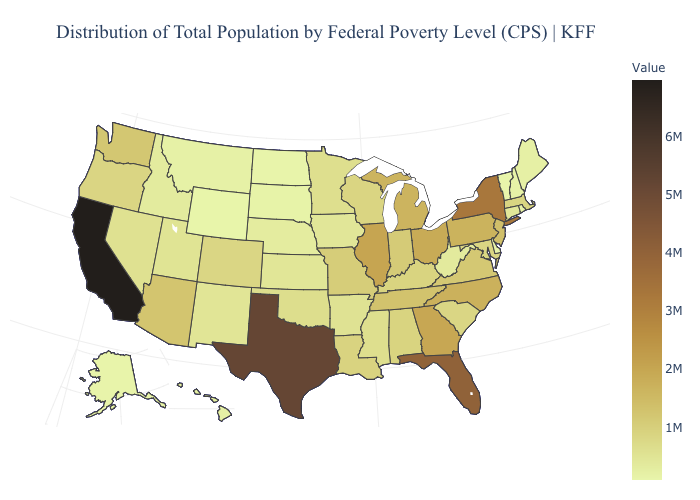Does South Carolina have a lower value than Alaska?
Give a very brief answer. No. Does New Mexico have a higher value than New York?
Keep it brief. No. Among the states that border Georgia , does Florida have the highest value?
Give a very brief answer. Yes. Does Maryland have a higher value than Illinois?
Write a very short answer. No. Which states have the lowest value in the USA?
Keep it brief. Vermont. Among the states that border Illinois , does Kentucky have the highest value?
Give a very brief answer. No. Does Louisiana have the lowest value in the USA?
Answer briefly. No. 